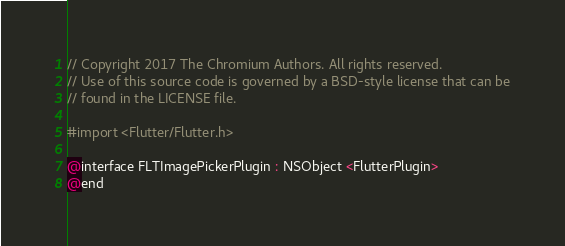Convert code to text. <code><loc_0><loc_0><loc_500><loc_500><_C_>// Copyright 2017 The Chromium Authors. All rights reserved.
// Use of this source code is governed by a BSD-style license that can be
// found in the LICENSE file.

#import <Flutter/Flutter.h>

@interface FLTImagePickerPlugin : NSObject <FlutterPlugin>
@end
</code> 